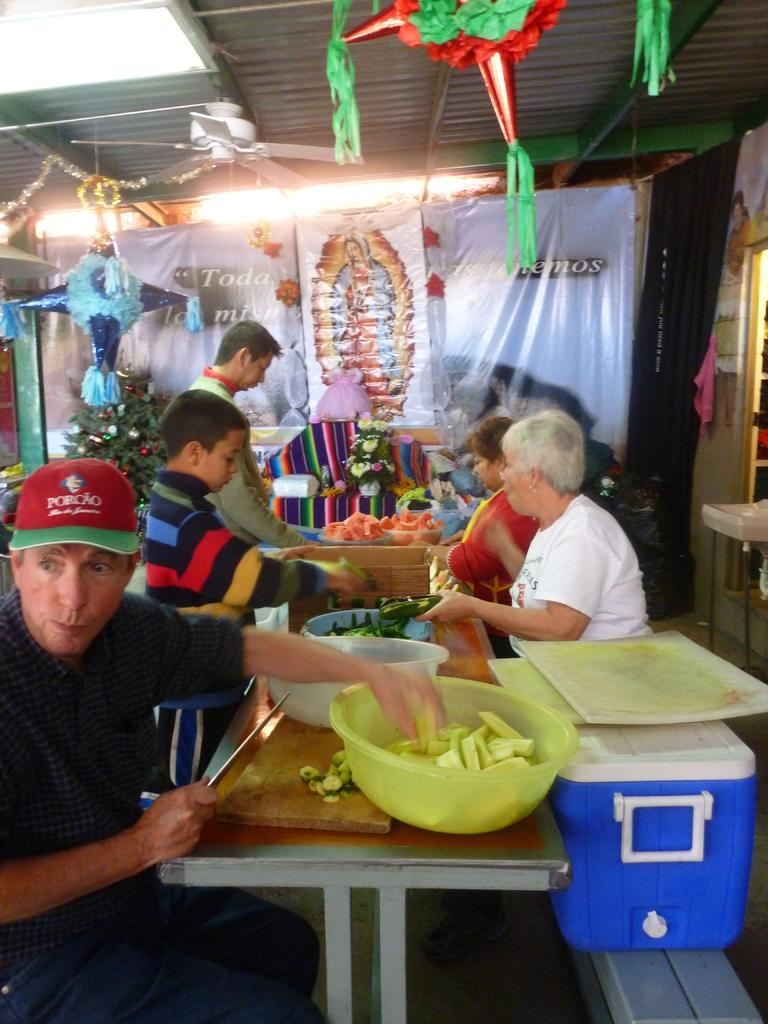How many people are in the image? There are persons in the image, but the exact number is not specified. What are the tables in front of the persons used for? The tables have bowls full of food on them, suggesting they are used for serving or eating food. What can be seen in the background of the image? There are decorations, a fan, and a banner in the background of the image. What type of punishment is being administered to the persons in the image? There is no indication of punishment in the image; the persons are simply sitting at tables with bowls of food. How long does it take for the minute hand to move in the image? There is no clock or time-related element in the image, so it is not possible to determine the movement of the minute hand. 